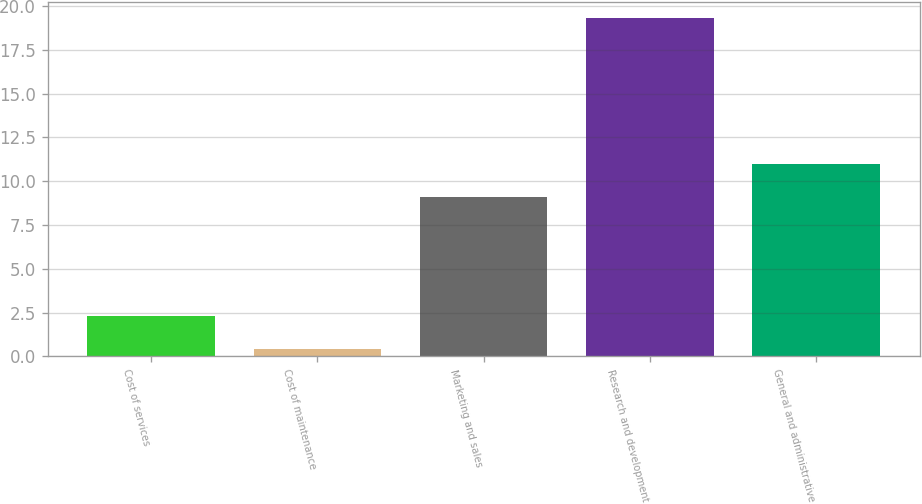<chart> <loc_0><loc_0><loc_500><loc_500><bar_chart><fcel>Cost of services<fcel>Cost of maintenance<fcel>Marketing and sales<fcel>Research and development<fcel>General and administrative<nl><fcel>2.29<fcel>0.4<fcel>9.1<fcel>19.3<fcel>10.99<nl></chart> 